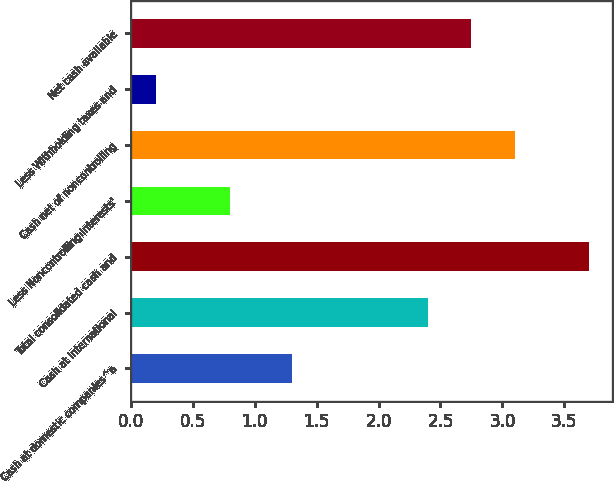Convert chart. <chart><loc_0><loc_0><loc_500><loc_500><bar_chart><fcel>Cash at domestic companies^a<fcel>Cash at international<fcel>Total consolidated cash and<fcel>Less Noncontrolling interests'<fcel>Cash net of noncontrolling<fcel>Less Withholding taxes and<fcel>Net cash available<nl><fcel>1.3<fcel>2.4<fcel>3.7<fcel>0.8<fcel>3.1<fcel>0.2<fcel>2.75<nl></chart> 